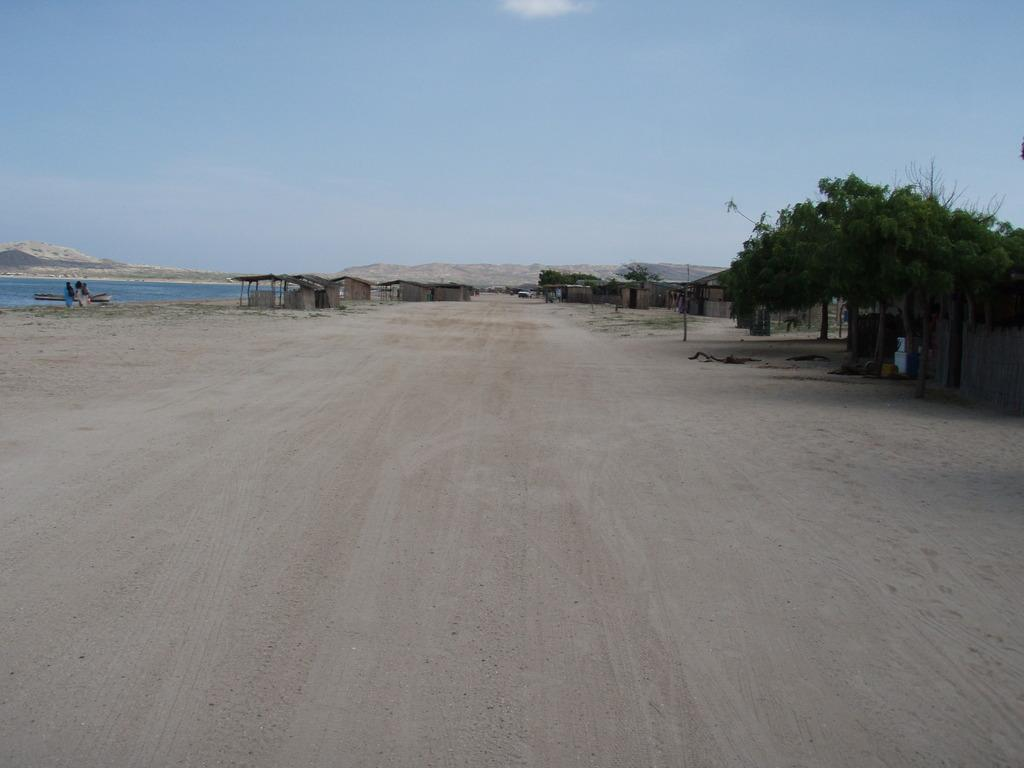What type of natural landscape can be seen in the image? The image features houses, trees, mountains, water, and a blue sky, indicating a natural landscape. Can you describe the bodies of water visible in the image? The image shows water, but it does not provide specific details about the bodies of water. What type of vegetation is present in the image? Trees are visible in the image. What is the color of the sky in the image? The sky is blue in the image. What type of trouble can be seen in the image? There is no indication of trouble in the image; it features a natural landscape with houses, trees, mountains, water, and a blue sky. What type of farm is depicted in the image? There is no farm present in the image; it features a natural landscape with houses, trees, mountains, water, and a blue sky. 